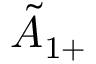Convert formula to latex. <formula><loc_0><loc_0><loc_500><loc_500>{ \tilde { A } } _ { 1 + }</formula> 